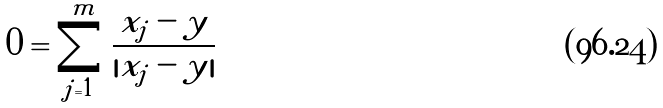Convert formula to latex. <formula><loc_0><loc_0><loc_500><loc_500>0 = \sum _ { j = 1 } ^ { m } \frac { x _ { j } - y } { | x _ { j } - y | }</formula> 